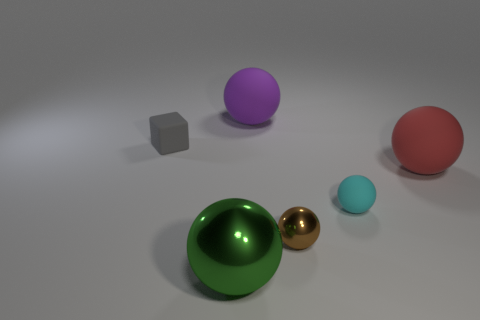How many balls are behind the tiny cyan matte thing and left of the large purple rubber thing?
Your answer should be compact. 0. The small gray thing that is made of the same material as the small cyan ball is what shape?
Your response must be concise. Cube. There is a purple ball that is behind the large red ball; is it the same size as the metal object on the right side of the purple rubber ball?
Your answer should be compact. No. There is a metal thing that is to the right of the big metallic object; what is its color?
Make the answer very short. Brown. What material is the large red ball in front of the thing behind the tiny gray thing?
Your answer should be very brief. Rubber. What shape is the gray object?
Provide a succinct answer. Cube. There is a red thing that is the same shape as the green shiny object; what is it made of?
Provide a succinct answer. Rubber. What number of gray things have the same size as the red object?
Keep it short and to the point. 0. There is a large matte sphere that is on the left side of the tiny cyan matte thing; are there any big red balls behind it?
Ensure brevity in your answer.  No. The tiny shiny ball is what color?
Provide a short and direct response. Brown. 